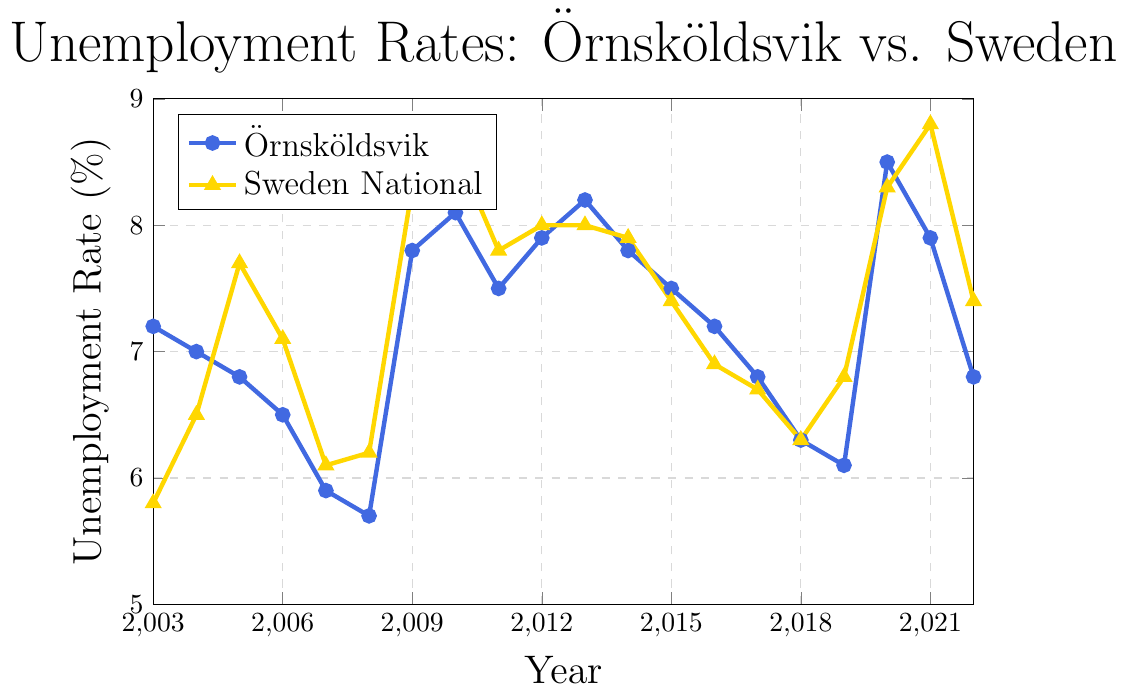What was the highest unemployment rate in Örnsköldsvik during the period 2003-2022? To find the highest unemployment rate in Örnsköldsvik, look for the highest peak in the Örnsköldsvik line (marked with circles) on the graph. The highest point occurs in 2020 at 8.5%.
Answer: 8.5% Which year did Örnsköldsvik have the same unemployment rate as the national average? To find the year when Örnsköldsvik's rate matched the national rate, locate where the blue line (Örnsköldsvik) and the yellow line (Sweden) intersect. This happens in 2018, where both have a rate of 6.3%.
Answer: 2018 How did the unemployment rate in Örnsköldsvik change from 2019 to 2020? Identify the unemployment rates in Örnsköldsvik for 2019 and 2020, then calculate the difference. In 2019, it was 6.1%, and in 2020, it was 8.5%. The change is 8.5% - 6.1% = 2.4%.
Answer: Increased by 2.4% What is the average unemployment rate in Örnsköldsvik for the period 2006-2010? Calculate the average by summing the rates from 2006 to 2010 and dividing by 5. The rates are 6.5%, 5.9%, 5.7%, 7.8%, and 8.1%, giving a sum of 34.0% and an average of 34.0% / 5 = 6.8%.
Answer: 6.8% In which year was the gap between Örnsköldsvik's and the national unemployment rate the largest? Compute the differences for each year and identify the maximum. The largest gap is in 2017, where the rate difference is 6.8% - 6.7% = 0.1%.
Answer: 2017 Between which years did the unemployment rate in Sweden experience the steepest rise? Look for the steepest upward slope in the national rate line (yellow line). The steepest rise occurs between 2004 and 2005, where the rate increased from 6.5% to 7.7%, a difference of 1.2%.
Answer: 2004 to 2005 How many years did Örnsköldsvik have a lower unemployment rate than the national average? Count the number of years where the blue line is below the yellow line. These years are 2003, 2004, 2005, 2006, 2007, 2008, 2009, 2010, 2011, 2012, 2013, 2014, 2018, and 2019, totaling 14 years.
Answer: 14 years What were the observations for 2020 in Örnsköldsvik and nationally? Locate the values for 2020 on both lines. For Örnsköldsvik, the rate is 8.5%, and nationally, it's 8.3%.
Answer: Örnsköldsvik: 8.5%, National: 8.3% What is the trend in unemployment rates for Örnsköldsvik from 2013 to 2018? Observe the direction of the blue line from 2013 to 2018. The unemployment rate in Örnsköldsvik generally decreases from 8.2% to 6.3% during this period.
Answer: Decreasing trend 